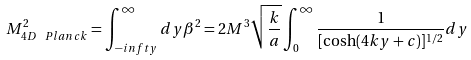Convert formula to latex. <formula><loc_0><loc_0><loc_500><loc_500>M ^ { 2 } _ { 4 D \ P l a n c k } = \int _ { - i n f t y } ^ { \infty } d y \beta ^ { 2 } = 2 M ^ { 3 } \sqrt { \frac { k } { a } } \int _ { 0 } ^ { \infty } \frac { 1 } { [ \cosh ( 4 k y + c ) ] ^ { 1 / 2 } } d y</formula> 